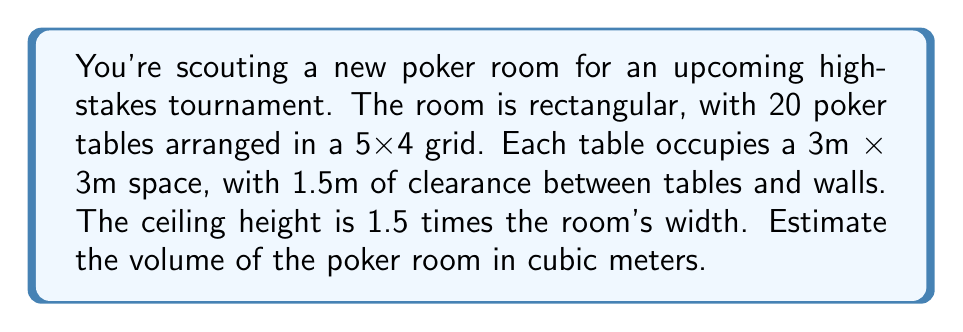Help me with this question. Let's approach this step-by-step:

1) First, let's calculate the length and width of the room:

   Length: 5 tables + 6 spaces for clearance
   $$ L = (5 \times 3\text{m}) + (6 \times 1.5\text{m}) = 15\text{m} + 9\text{m} = 24\text{m} $$

   Width: 4 tables + 5 spaces for clearance
   $$ W = (4 \times 3\text{m}) + (5 \times 1.5\text{m}) = 12\text{m} + 7.5\text{m} = 19.5\text{m} $$

2) The height is 1.5 times the width:
   $$ H = 1.5 \times 19.5\text{m} = 29.25\text{m} $$

3) Now we can calculate the volume using the formula for a rectangular prism:
   $$ V = L \times W \times H $$

4) Substituting our values:
   $$ V = 24\text{m} \times 19.5\text{m} \times 29.25\text{m} $$

5) Calculating:
   $$ V = 13,689 \text{m}^3 $$

This large volume allows for ample space above the tables, which could accommodate lighting, ventilation systems, and even a mezzanine for spectators or security personnel.
Answer: The estimated volume of the poker room is 13,689 cubic meters. 